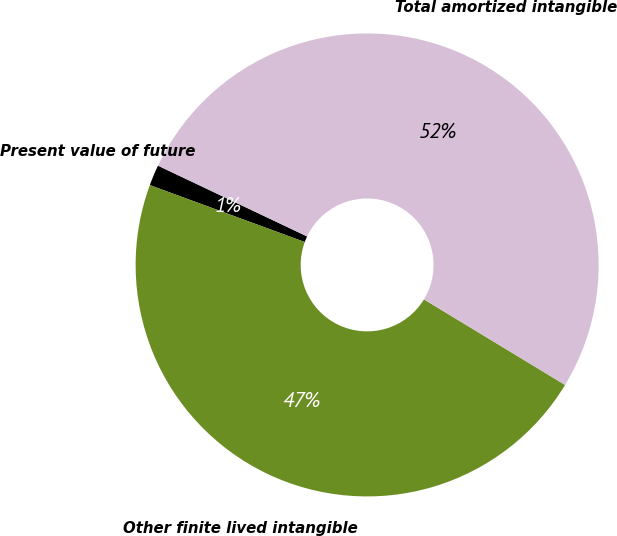Convert chart to OTSL. <chart><loc_0><loc_0><loc_500><loc_500><pie_chart><fcel>Present value of future<fcel>Other finite lived intangible<fcel>Total amortized intangible<nl><fcel>1.45%<fcel>46.93%<fcel>51.62%<nl></chart> 